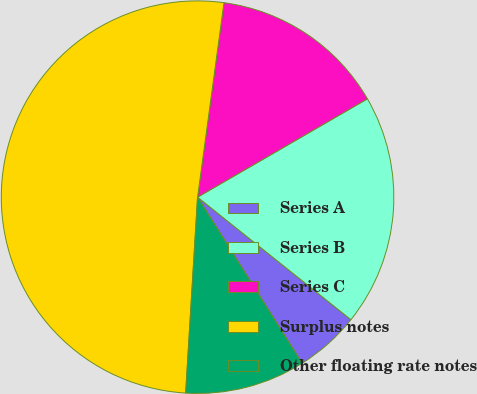<chart> <loc_0><loc_0><loc_500><loc_500><pie_chart><fcel>Series A<fcel>Series B<fcel>Series C<fcel>Surplus notes<fcel>Other floating rate notes<nl><fcel>5.33%<fcel>19.08%<fcel>14.5%<fcel>51.18%<fcel>9.91%<nl></chart> 